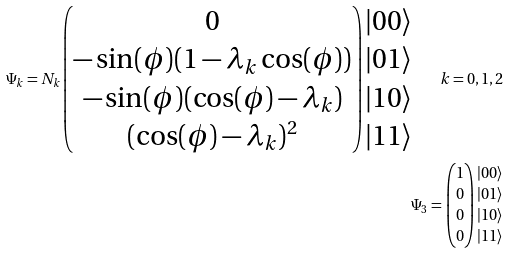Convert formula to latex. <formula><loc_0><loc_0><loc_500><loc_500>\Psi _ { k } = N _ { k } \begin{pmatrix} 0 \\ - \sin ( \phi ) ( 1 - \lambda _ { k } \cos ( \phi ) ) \\ - \sin ( \phi ) ( \cos ( \phi ) - \lambda _ { k } ) \\ ( \cos ( \phi ) - \lambda _ { k } ) ^ { 2 } \end{pmatrix} \begin{matrix} | 0 0 \rangle \\ | 0 1 \rangle \\ | 1 0 \rangle \\ | 1 1 \rangle \end{matrix} \quad k = 0 , 1 , 2 \\ \Psi _ { 3 } = \begin{pmatrix} 1 \\ 0 \\ 0 \\ 0 \end{pmatrix} \begin{matrix} | 0 0 \rangle \\ | 0 1 \rangle \\ | 1 0 \rangle \\ | 1 1 \rangle \end{matrix}</formula> 